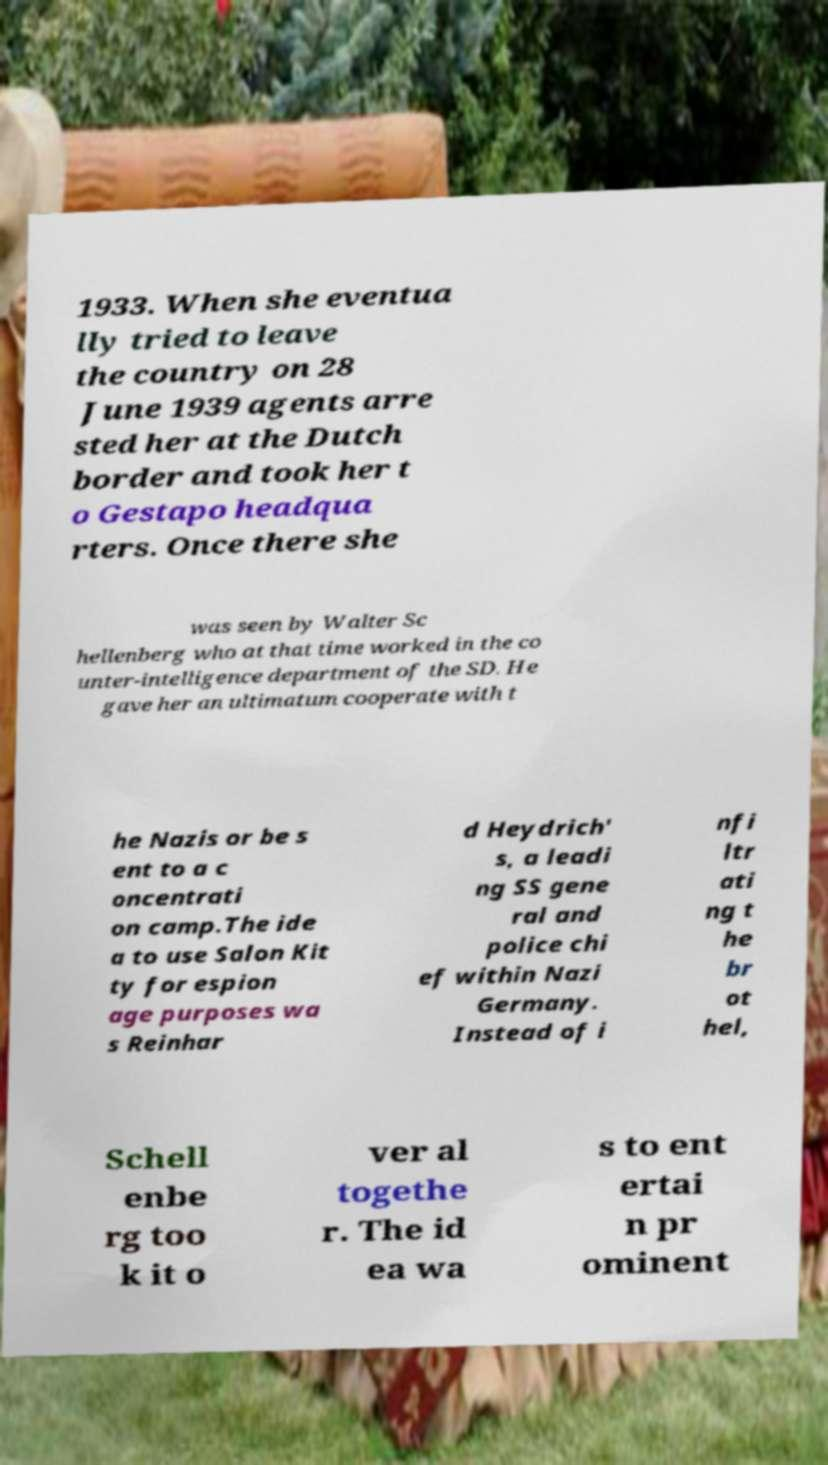Can you accurately transcribe the text from the provided image for me? 1933. When she eventua lly tried to leave the country on 28 June 1939 agents arre sted her at the Dutch border and took her t o Gestapo headqua rters. Once there she was seen by Walter Sc hellenberg who at that time worked in the co unter-intelligence department of the SD. He gave her an ultimatum cooperate with t he Nazis or be s ent to a c oncentrati on camp.The ide a to use Salon Kit ty for espion age purposes wa s Reinhar d Heydrich' s, a leadi ng SS gene ral and police chi ef within Nazi Germany. Instead of i nfi ltr ati ng t he br ot hel, Schell enbe rg too k it o ver al togethe r. The id ea wa s to ent ertai n pr ominent 